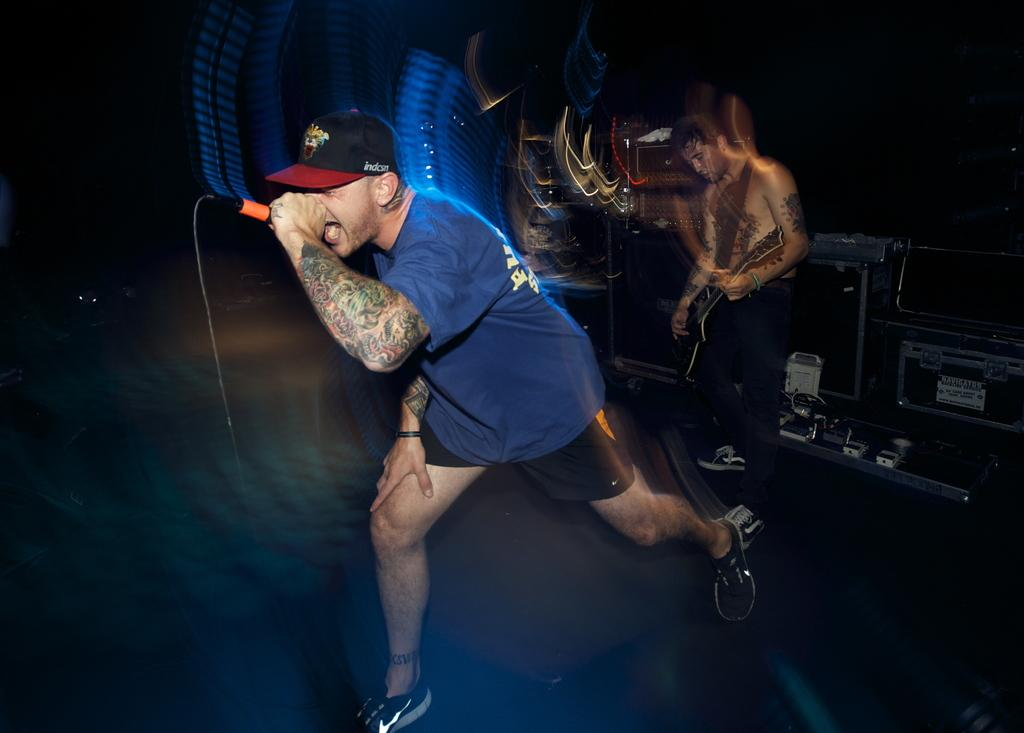What is the man in the image doing? The man is singing in the image. What is the man holding while singing? The man is holding a microphone. Can you describe the other person in the image? There is another person playing a guitar in the background. How would you describe the quality of the image? The image is blurry in the middle. Is there a veil covering the microphone in the image? No, there is no veil present in the image. How many sheep can be seen in the background of the image? There are no sheep visible in the image. 